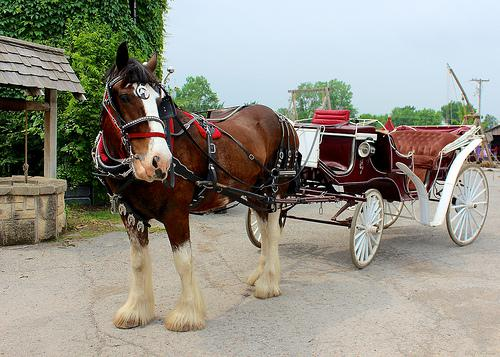Question: why is the carriage hooked up to the horse?
Choices:
A. To carry items.
B. To pull people.
C. To pull it.
D. To conrol the horses.
Answer with the letter. Answer: C Question: how many wheels are seen in photo?
Choices:
A. Three.
B. Two.
C. Four.
D. One.
Answer with the letter. Answer: C Question: who is driving the carriage?
Choices:
A. A man.
B. No one.
C. A lady.
D. A conducter.
Answer with the letter. Answer: B Question: where are the trees?
Choices:
A. On the left.
B. On the right.
C. Behind the house.
D. Background of picture.
Answer with the letter. Answer: D 